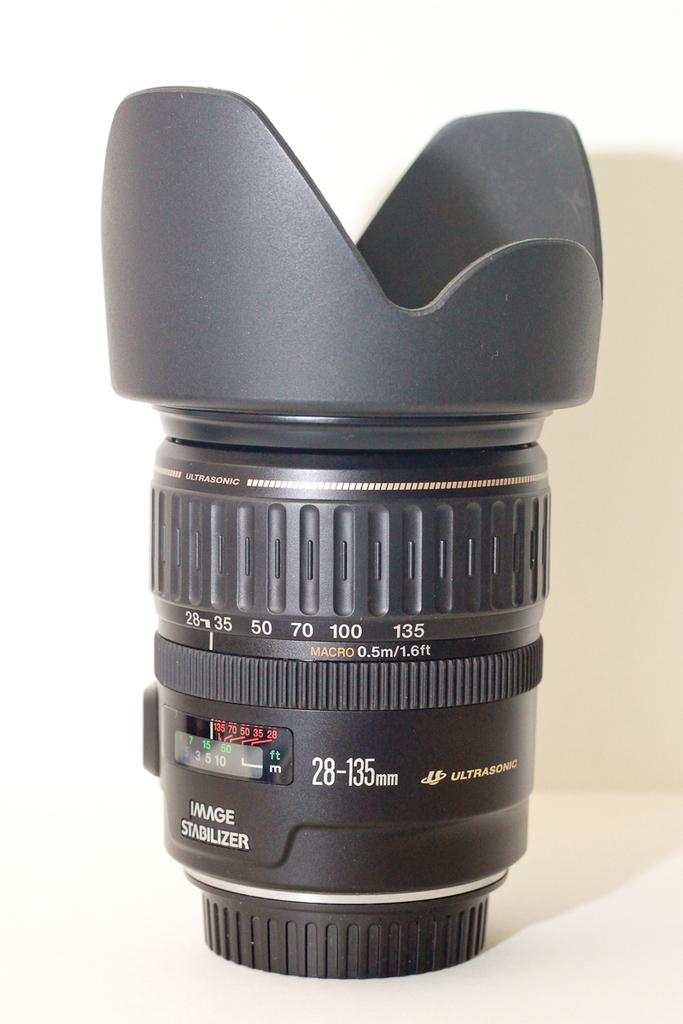What is the main subject of the image? The main subject of the image is a camera lens. Can you describe the position of the camera lens in the image? The camera lens is on a surface in the image. What color is the background of the image? The background of the image is white. What type of copper material is used to make the paper in the image? There is no paper or copper material present in the image; it only features a camera lens on a surface with a white backgrounds are in the image? 